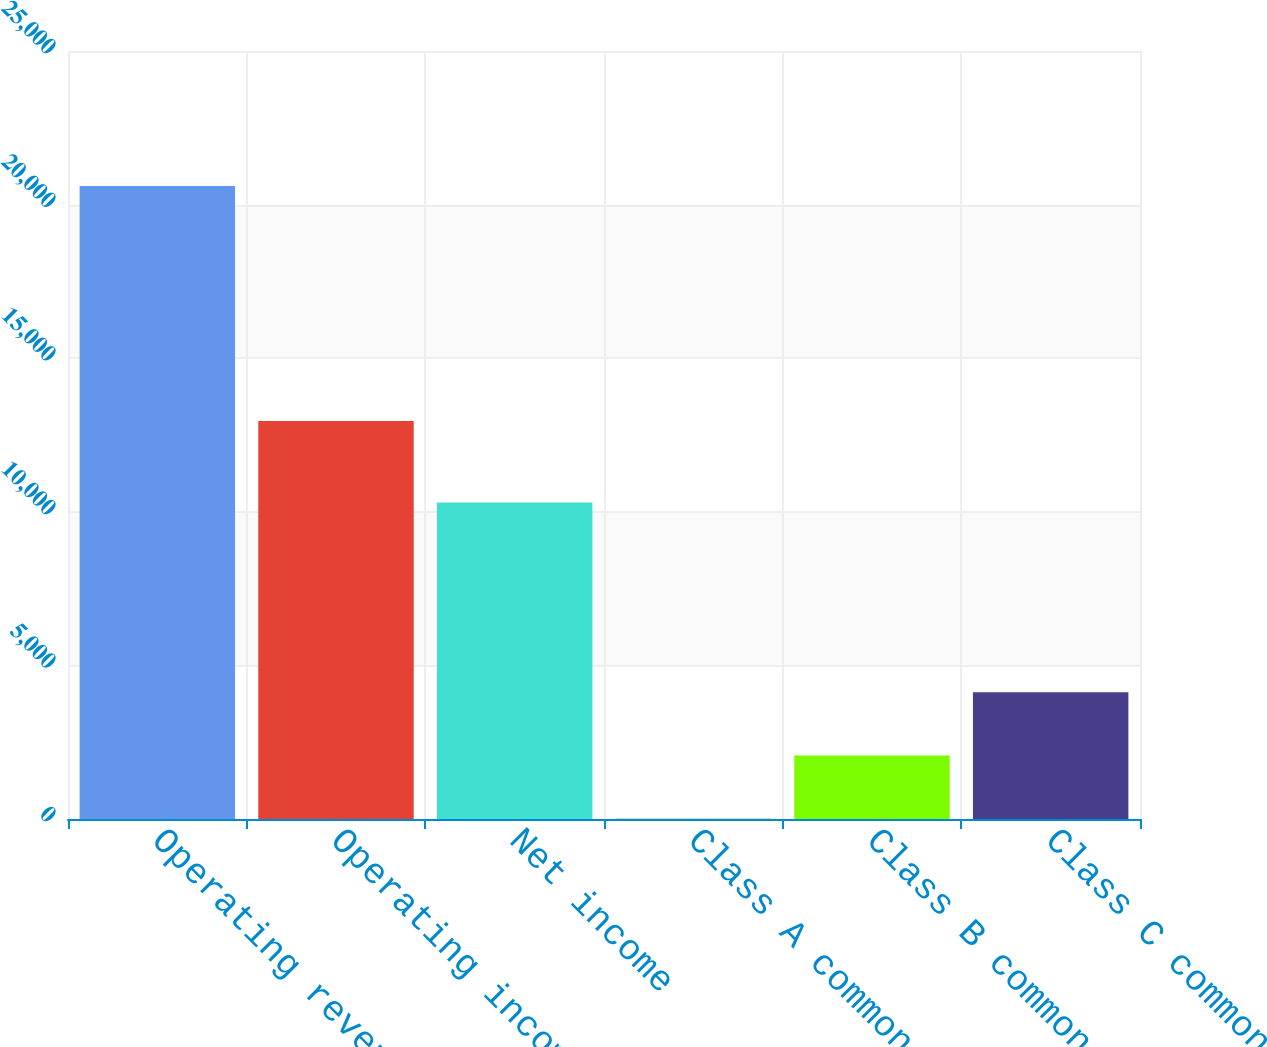<chart> <loc_0><loc_0><loc_500><loc_500><bar_chart><fcel>Operating revenues<fcel>Operating income<fcel>Net income<fcel>Class A common stock<fcel>Class B common stock<fcel>Class C common stock<nl><fcel>20609<fcel>12954<fcel>10301<fcel>4.43<fcel>2064.89<fcel>4125.35<nl></chart> 